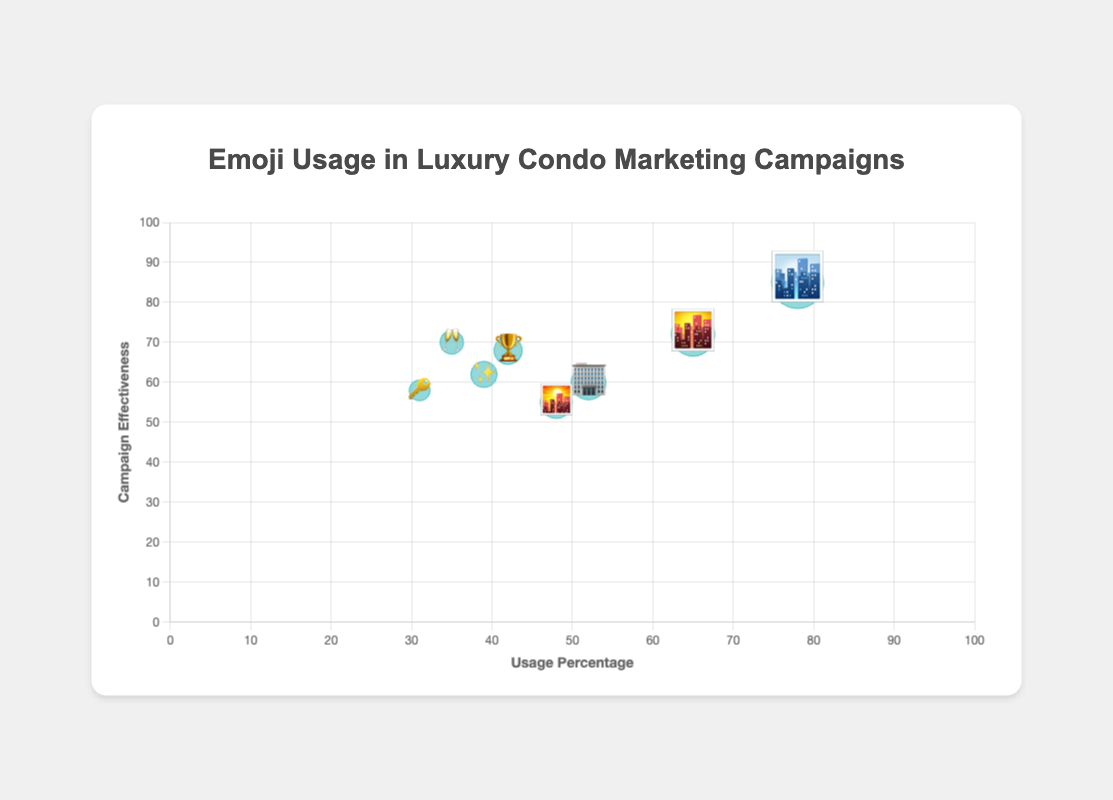What is the "Cityscape" emoji's usage percentage? The "Cityscape" emoji is the first data point on the plot with an x-coordinate representing the usage percentage. It has a usage percentage of 78%.
Answer: 78% Which emoji has the highest campaign effectiveness? The emoji with the highest y-coordinate represents the highest campaign effectiveness. "Cityscape" (🏙️) has the highest effectiveness of 85%.
Answer: 🏙️ How does the usage percentage of "Clinking Glasses" (🥂) compare to "Key" (🔑)? Look for the x-coordinates representing usage percentages for the "Clinking Glasses" and "Key" emojis. "Clinking Glasses" has a usage of 35%, and "Key" has 31%.
Answer: The usage of "Clinking Glasses" is 4% higher than "Key" What is the average campaign effectiveness of "City Sunset" (🌆) and "Office Building" (🏢)? Add the campaign effectiveness values of "City Sunset" (72%) and "Office Building" (60%), then divide by 2: (72 + 60) / 2 = 66%.
Answer: 66% Which emoji has the smallest bubble size, and what does it represent? The size of the bubbles reflects the usage percentage. "Key" (🔑) has the smallest bubble, representing 31% usage.
Answer: 🔑 Compare the usage percentages of "Trophy" (🏆) and "Sparkles" (✨). Which has a higher percentage? Check the x-coordinates for "Trophy" (42%) and "Sparkles" (39%). "Trophy" has a higher usage percentage.
Answer: 🏆 What is the total campaign effectiveness of the least used three emojis? Identify the three emojis with the lowest usage: "Key" (58%), "Clinking Glasses" (70%), and "Sparkles" (62%). Add their effectiveness values: 58 + 70 + 62 = 190%.
Answer: 190% Which emoji combines high usage percentage with high campaign effectiveness? Look for an emoji positioned relatively high and far right on the plot. "Cityscape" (🏙️) has both high usage (78%) and high effectiveness (85%).
Answer: 🏙️ What is the range of usage percentages in the dataset? Identify the minimum and maximum usage percentages: "Key" (31%) and "Cityscape" (78%). Subtract the minimum from the maximum: 78 - 31 = 47%.
Answer: 47% Which emoji is closest in usage percentage to the "City Sunrise" (🌇) emoji? Check the usage percentage of "City Sunrise" (48%) and compare it to others. "Office Building" (52%) is the closest with a difference of 4%.
Answer: 🏢 